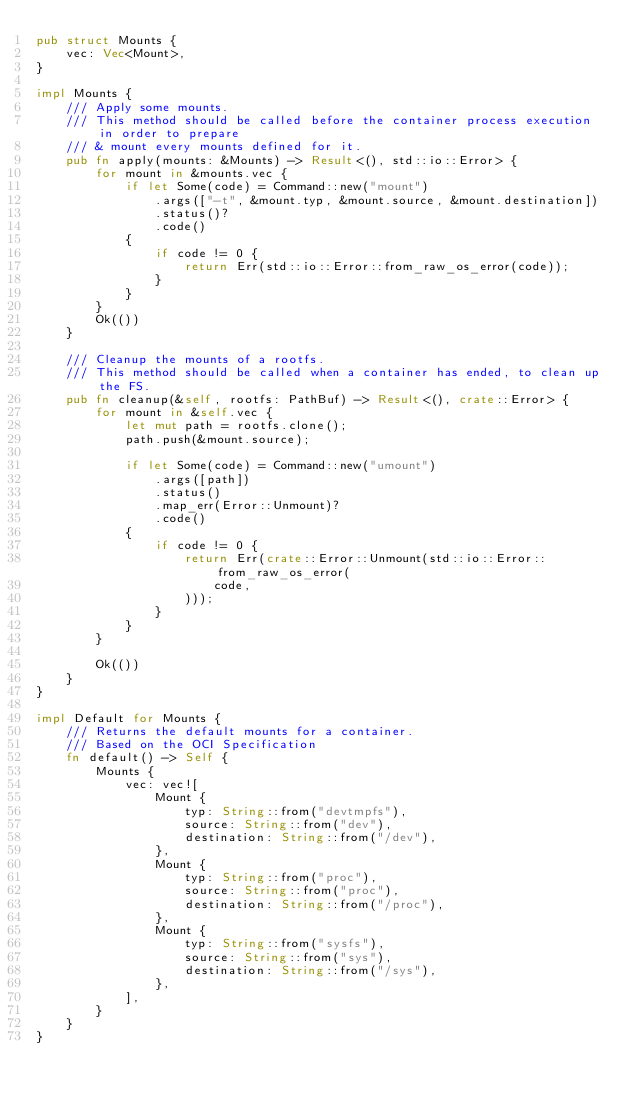<code> <loc_0><loc_0><loc_500><loc_500><_Rust_>pub struct Mounts {
    vec: Vec<Mount>,
}

impl Mounts {
    /// Apply some mounts.
    /// This method should be called before the container process execution in order to prepare
    /// & mount every mounts defined for it.
    pub fn apply(mounts: &Mounts) -> Result<(), std::io::Error> {
        for mount in &mounts.vec {
            if let Some(code) = Command::new("mount")
                .args(["-t", &mount.typ, &mount.source, &mount.destination])
                .status()?
                .code()
            {
                if code != 0 {
                    return Err(std::io::Error::from_raw_os_error(code));
                }
            }
        }
        Ok(())
    }

    /// Cleanup the mounts of a rootfs.
    /// This method should be called when a container has ended, to clean up the FS.
    pub fn cleanup(&self, rootfs: PathBuf) -> Result<(), crate::Error> {
        for mount in &self.vec {
            let mut path = rootfs.clone();
            path.push(&mount.source);

            if let Some(code) = Command::new("umount")
                .args([path])
                .status()
                .map_err(Error::Unmount)?
                .code()
            {
                if code != 0 {
                    return Err(crate::Error::Unmount(std::io::Error::from_raw_os_error(
                        code,
                    )));
                }
            }
        }

        Ok(())
    }
}

impl Default for Mounts {
    /// Returns the default mounts for a container.
    /// Based on the OCI Specification
    fn default() -> Self {
        Mounts {
            vec: vec![
                Mount {
                    typ: String::from("devtmpfs"),
                    source: String::from("dev"),
                    destination: String::from("/dev"),
                },
                Mount {
                    typ: String::from("proc"),
                    source: String::from("proc"),
                    destination: String::from("/proc"),
                },
                Mount {
                    typ: String::from("sysfs"),
                    source: String::from("sys"),
                    destination: String::from("/sys"),
                },
            ],
        }
    }
}
</code> 